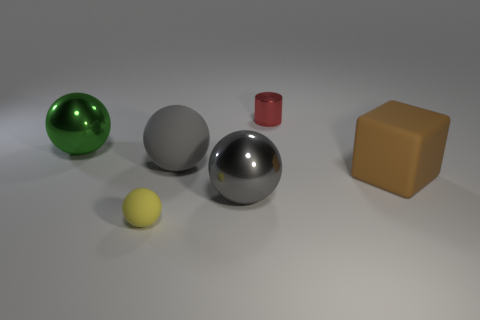Add 3 tiny red metallic objects. How many objects exist? 9 Subtract all yellow spheres. How many spheres are left? 3 Subtract all yellow balls. How many balls are left? 3 Subtract all yellow blocks. Subtract all gray cylinders. How many blocks are left? 1 Subtract all cyan balls. How many blue cylinders are left? 0 Subtract all big red cubes. Subtract all large brown things. How many objects are left? 5 Add 6 brown matte things. How many brown matte things are left? 7 Add 5 large gray matte balls. How many large gray matte balls exist? 6 Subtract 0 yellow blocks. How many objects are left? 6 Subtract all cubes. How many objects are left? 5 